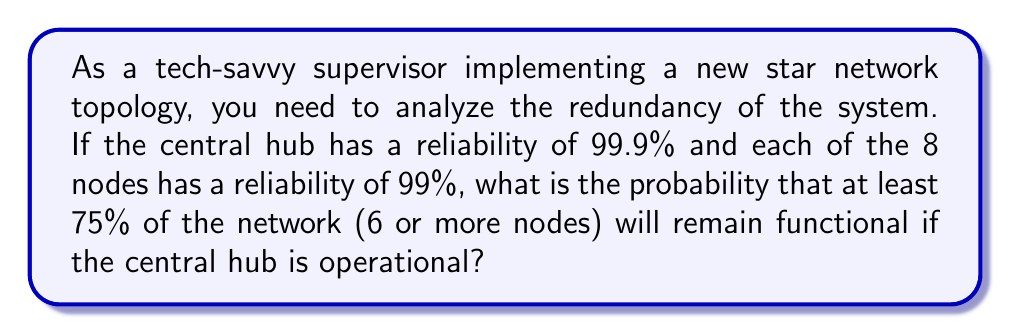Can you solve this math problem? Let's approach this step-by-step:

1) First, we need to calculate the probability of the central hub being operational:
   $P(\text{hub operational}) = 0.999$

2) Now, we need to calculate the probability of each node being operational:
   $P(\text{node operational}) = 0.99$
   $P(\text{node failure}) = 1 - 0.99 = 0.01$

3) We want at least 6 out of 8 nodes to be operational. This can happen in three ways:
   - All 8 nodes operational
   - 7 nodes operational and 1 failed
   - 6 nodes operational and 2 failed

4) Let's calculate each of these probabilities using the binomial distribution:

   $P(8 \text{ operational}) = \binom{8}{8} (0.99)^8 = 0.99^8 \approx 0.9227$

   $P(7 \text{ operational}) = \binom{8}{7} (0.99)^7 (0.01) = 8 \cdot 0.99^7 \cdot 0.01 \approx 0.0747$

   $P(6 \text{ operational}) = \binom{8}{6} (0.99)^6 (0.01)^2 = 28 \cdot 0.99^6 \cdot 0.01^2 \approx 0.0026$

5) The total probability of at least 75% of the network remaining functional, given that the hub is operational:

   $P(\text{at least 75% functional | hub operational}) = 0.9227 + 0.0747 + 0.0026 = 1$

6) Finally, we multiply this by the probability of the hub being operational:

   $P(\text{at least 75% functional and hub operational}) = 1 \cdot 0.999 = 0.999$
Answer: The probability that at least 75% of the network (6 or more nodes) will remain functional if the central hub is operational is 0.999 or 99.9%. 